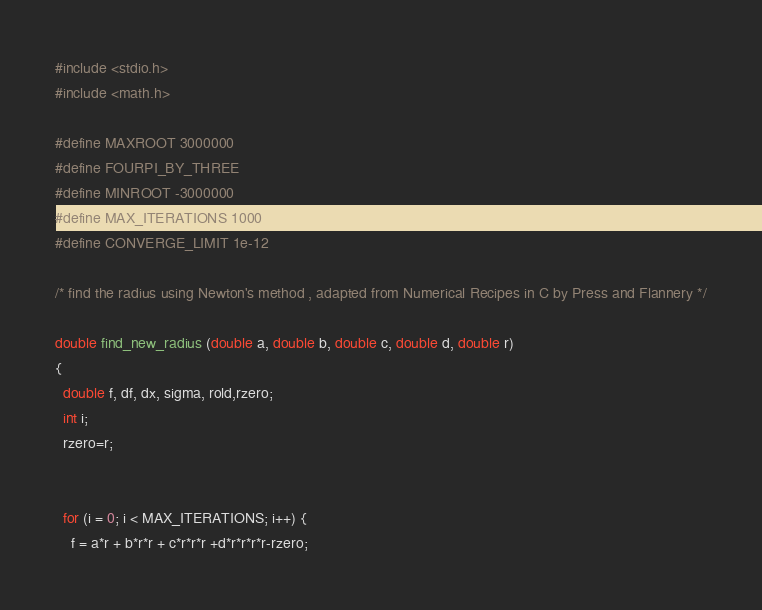<code> <loc_0><loc_0><loc_500><loc_500><_C_>
#include <stdio.h>
#include <math.h>

#define MAXROOT 3000000
#define FOURPI_BY_THREE 
#define MINROOT -3000000
#define MAX_ITERATIONS 1000
#define CONVERGE_LIMIT 1e-12

/* find the radius using Newton's method , adapted from Numerical Recipes in C by Press and Flannery */

double find_new_radius (double a, double b, double c, double d, double r)
{
  double f, df, dx, sigma, rold,rzero;
  int i;
  rzero=r;


  for (i = 0; i < MAX_ITERATIONS; i++) {
    f = a*r + b*r*r + c*r*r*r +d*r*r*r*r-rzero;</code> 